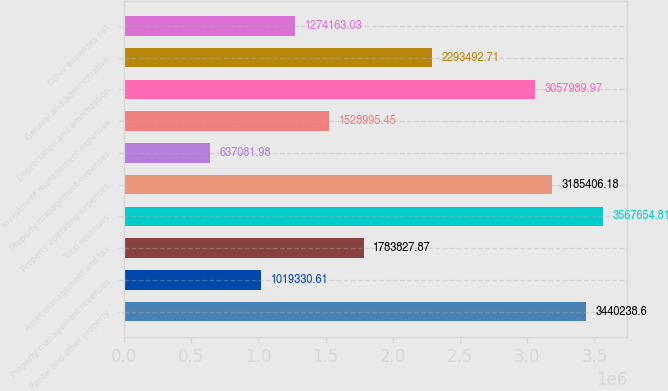Convert chart to OTSL. <chart><loc_0><loc_0><loc_500><loc_500><bar_chart><fcel>Rental and other property<fcel>Property management revenues<fcel>Asset management and tax<fcel>Total revenues<fcel>Property operating expenses<fcel>Property management expenses<fcel>Investment management expenses<fcel>Depreciation and amortization<fcel>General and administrative<fcel>Other expenses net<nl><fcel>3.44024e+06<fcel>1.01933e+06<fcel>1.78383e+06<fcel>3.56765e+06<fcel>3.18541e+06<fcel>637082<fcel>1.529e+06<fcel>3.05799e+06<fcel>2.29349e+06<fcel>1.27416e+06<nl></chart> 